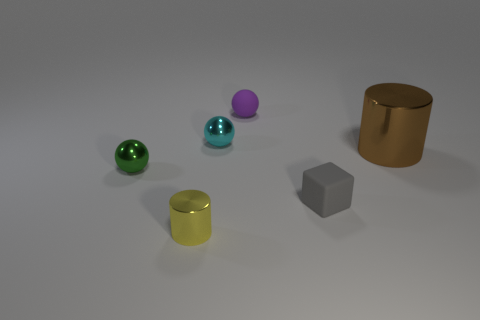Add 1 small balls. How many objects exist? 7 Subtract all cylinders. How many objects are left? 4 Subtract all tiny purple spheres. Subtract all big gray matte spheres. How many objects are left? 5 Add 3 tiny metallic cylinders. How many tiny metallic cylinders are left? 4 Add 6 small blue matte blocks. How many small blue matte blocks exist? 6 Subtract 0 brown balls. How many objects are left? 6 